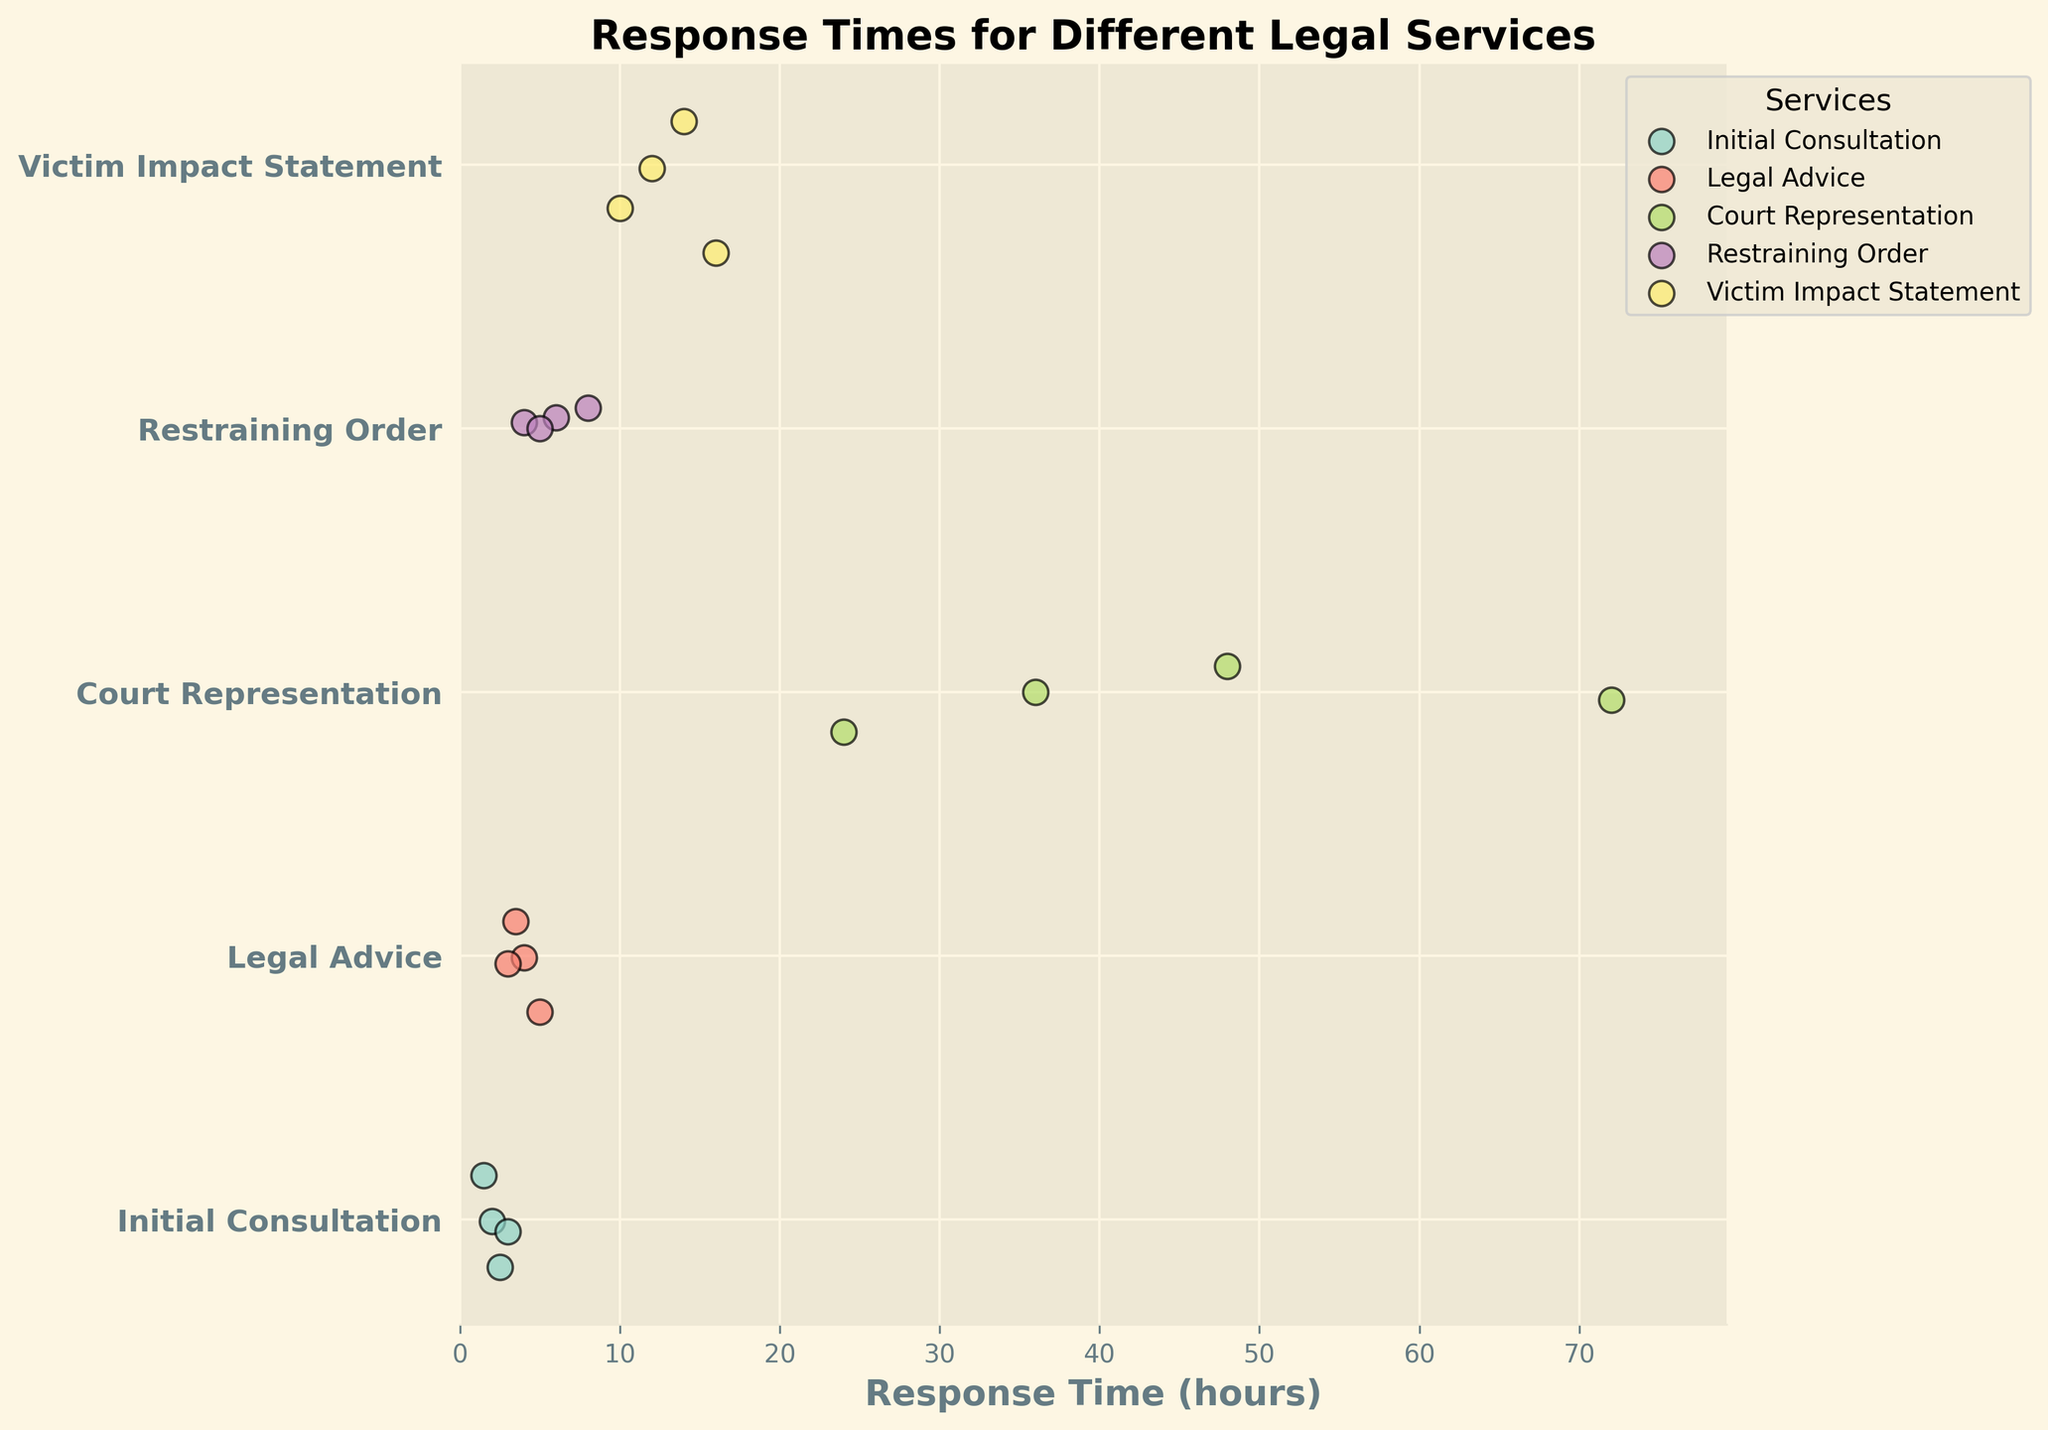What is the title of the plot? The title is located at the top of the plot and provides a clear description of what the figure represents.
Answer: Response Times for Different Legal Services How many types of legal services are shown in the plot? The number of unique services can be identified by counting the distinct y-axis labels on the left side of the plot.
Answer: 5 Which service has the longest maximum response time? By examining the horizontal dispersion of dots within each service group, the service with the furthest right point represents the longest maximum response time.
Answer: Court Representation What is the range of response times for the Initial Consultation service? Calculate the range by subtracting the minimum response time from the maximum response time for Initial Consultation. The scatter points for Initial Consultation are located on the left side of the plot.
Answer: 1.5 to 3 hours Which service has more variability in response times: Restraining Order or Legal Advice? Compare the horizontal spread of the scatter points for the two services; the one with a wider spread has more variability.
Answer: Legal Advice What is the average response time for Victim Impact Statement? Average the response times by identifying the scatter points on the x-axis for Victim Impact Statement and calculating their mean.
Answer: 13 hours Which service has the most dispersed data points? Assess all service groups, looking for the group with the widest horizontal spread of scatter points.
Answer: Court Representation Are there any services with an average response time below 10 hours? Calculate the average response times for each service. Services with averages below 10 hours can be identified by examining the scatter points and computing their mean.
Answer: Initial Consultation, Legal Advice, Restraining Order Which service has the smallest range of response times? The range is determined by the difference between the maximum and minimum response times for each service. The group with the smallest range will have the least horizontal spread.
Answer: Initial Consultation Are there any overlaps in response times between Legal Advice and Restraining Order services? Review the scatter points for both Legal Advice and Restraining Order and check for any areas where dot positions on the horizontal axis coincide.
Answer: Yes 